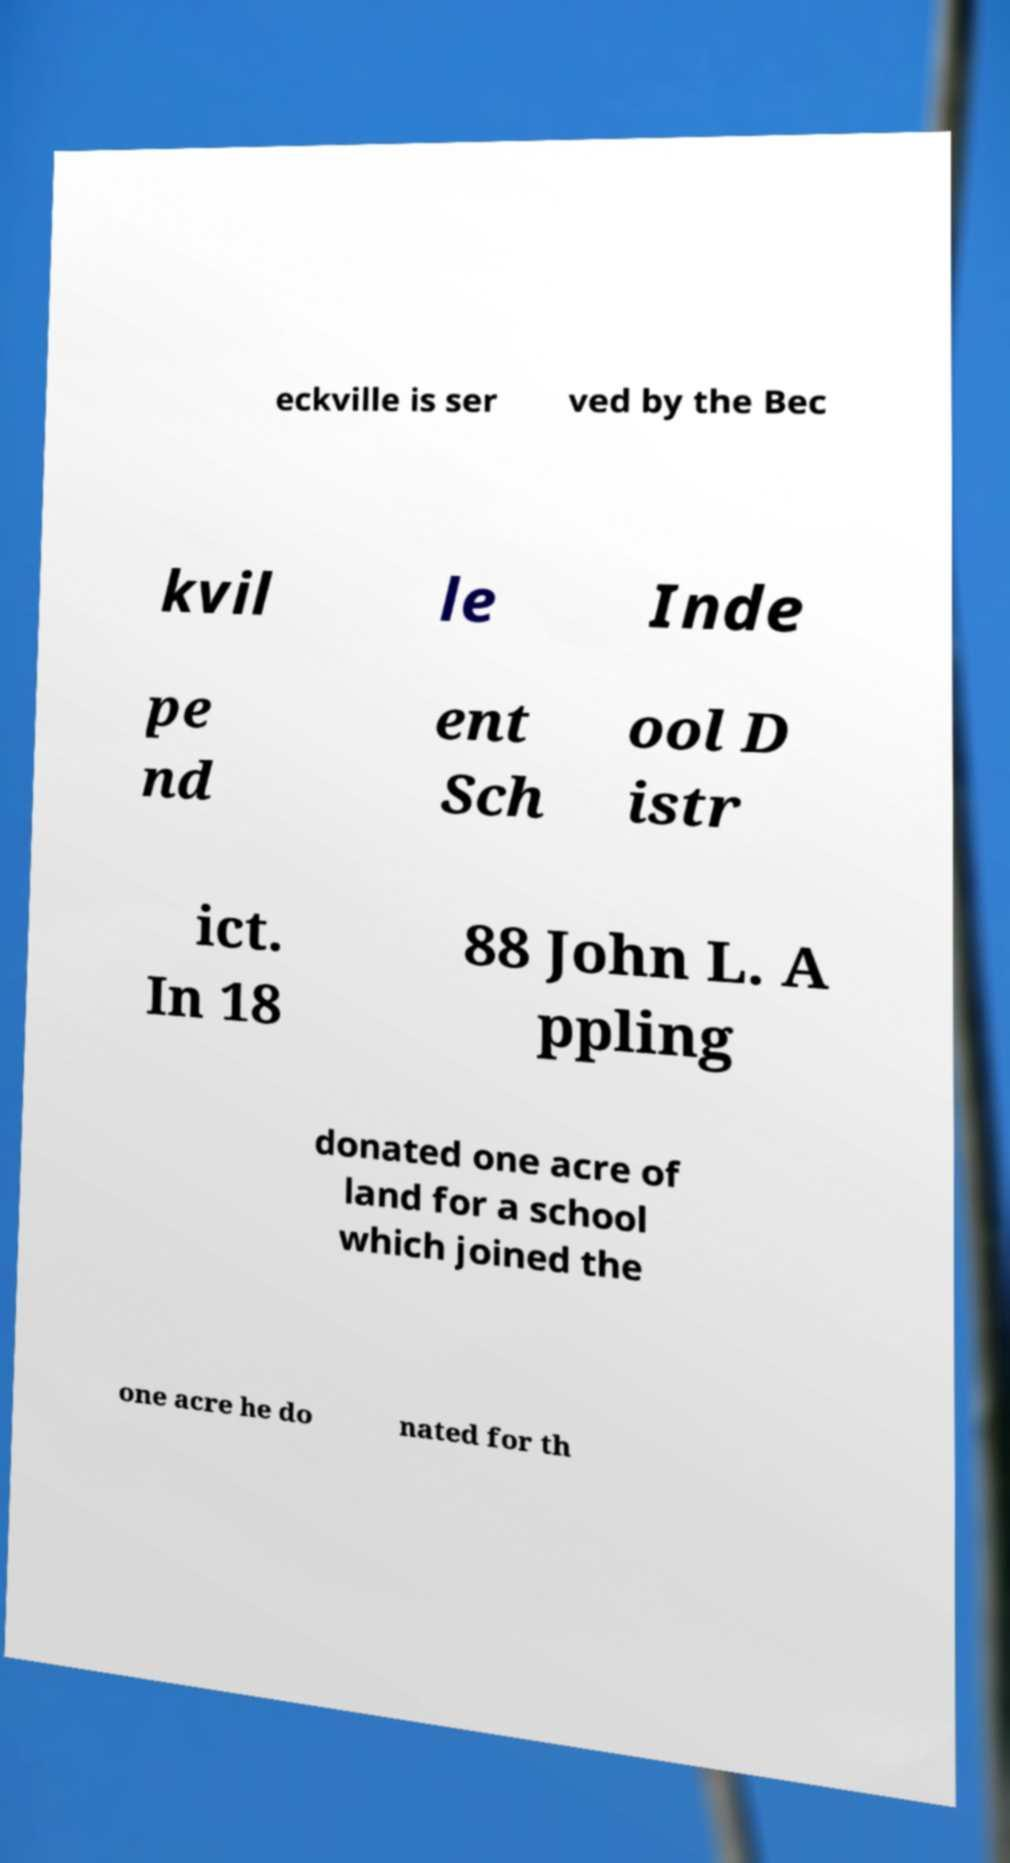For documentation purposes, I need the text within this image transcribed. Could you provide that? eckville is ser ved by the Bec kvil le Inde pe nd ent Sch ool D istr ict. In 18 88 John L. A ppling donated one acre of land for a school which joined the one acre he do nated for th 